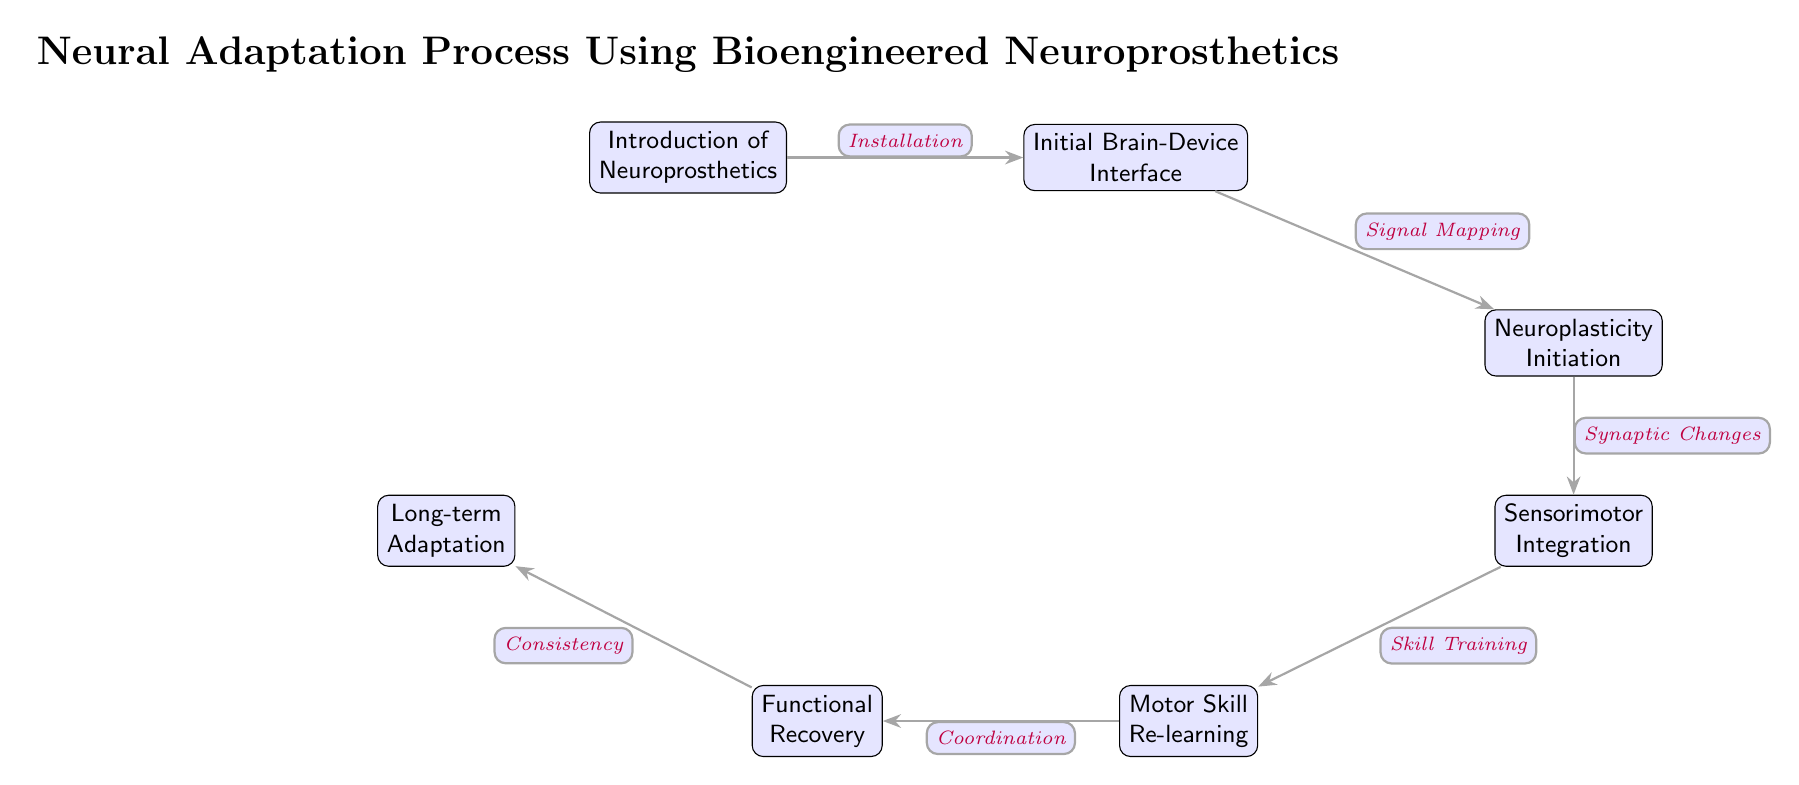What is the first stage of the process? The diagram shows that the first stage is labeled "Introduction of Neuroprosthetics," indicating the starting point of the neural adaptation process.
Answer: Introduction of Neuroprosthetics How many nodes are present in the diagram? By counting each labeled stage in the diagram, there are a total of seven nodes representing the stages of the neural adaptation process.
Answer: 7 What action follows "Signal Mapping"? The diagram indicates that the action following "Signal Mapping" is "Neuroplasticity Initiation," marking the transition from the brain-device interface to the beginning of neuroplastic changes.
Answer: Neuroplasticity Initiation What is the relationship between "Functional Recovery" and "Motor Skill Re-learning"? The diagram shows that "Functional Recovery" is directly influenced by "Motor Skill Re-learning," illustrating that improvements in motor skills are a necessary part of achieving functional recovery.
Answer: Motor Skill Re-learning What is the last stage of the process? The last stage in the diagram is labeled "Long-term Adaptation," which signifies the final goal of the neuroprosthetic intervention.
Answer: Long-term Adaptation How does "Sensorimotor Integration" relate to "Neuroplasticity Initiation"? "Sensorimotor Integration" follows "Neuroplasticity Initiation" in the flow of the diagram, implying that the initiation of neuroplasticity leads to integrating sensory and motor functions.
Answer: Leads to What processes modify brain connections at "Neuroplasticity Initiation"? The diagram mentions "Synaptic Changes" as the process that occurs at "Neuroplasticity Initiation," which indicates that this stage involves modifications to the connections between neurons.
Answer: Synaptic Changes Which two stages are directly connected by "Coordination"? In the diagram, "Coordination" connects "Motor Skill Re-learning" and "Functional Recovery," illustrating the relationship that skills learned must be coordinated to achieve recovery.
Answer: Motor Skill Re-learning and Functional Recovery What does "Skill Training" lead to in the diagram? The diagram shows that "Skill Training" leads to "Motor Skill Re-learning," indicating that the training of skills is essential for relearning them to regain functionality.
Answer: Motor Skill Re-learning 